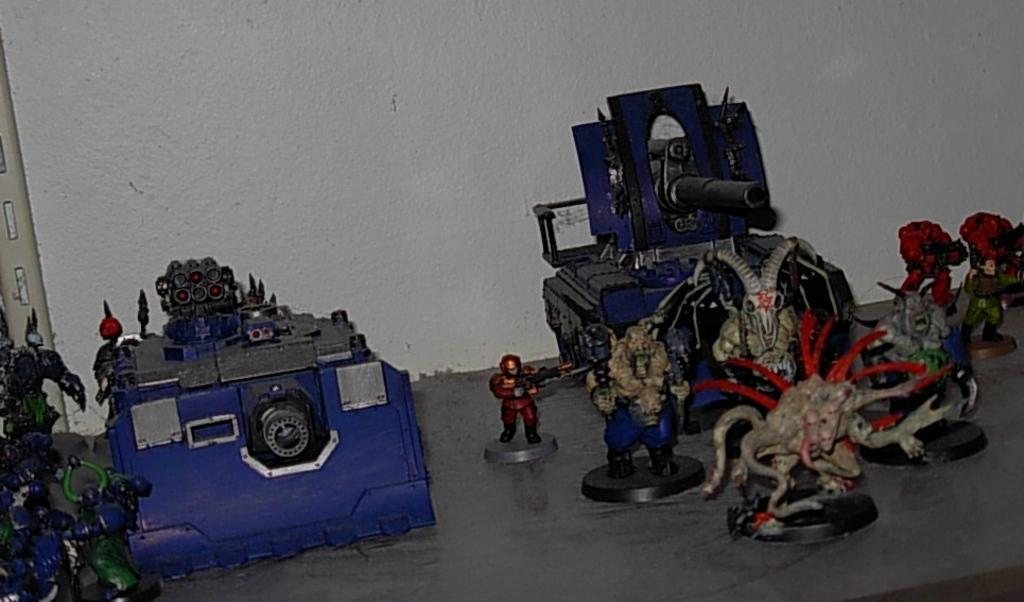What objects can be seen on the right side of the image? There are toys on the right side of the image. What is located in the middle of the image? There is a wall in the middle of the image. Can you see a bat flying near the toys in the image? There is no bat visible in the image; it only features toys and a wall. Is there an iron being used to press clothes in the image? There is no iron present in the image. 